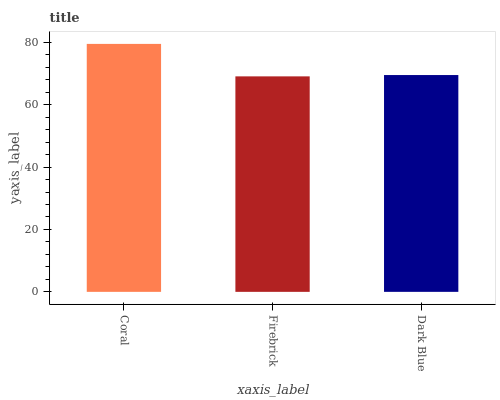Is Firebrick the minimum?
Answer yes or no. Yes. Is Coral the maximum?
Answer yes or no. Yes. Is Dark Blue the minimum?
Answer yes or no. No. Is Dark Blue the maximum?
Answer yes or no. No. Is Dark Blue greater than Firebrick?
Answer yes or no. Yes. Is Firebrick less than Dark Blue?
Answer yes or no. Yes. Is Firebrick greater than Dark Blue?
Answer yes or no. No. Is Dark Blue less than Firebrick?
Answer yes or no. No. Is Dark Blue the high median?
Answer yes or no. Yes. Is Dark Blue the low median?
Answer yes or no. Yes. Is Coral the high median?
Answer yes or no. No. Is Firebrick the low median?
Answer yes or no. No. 